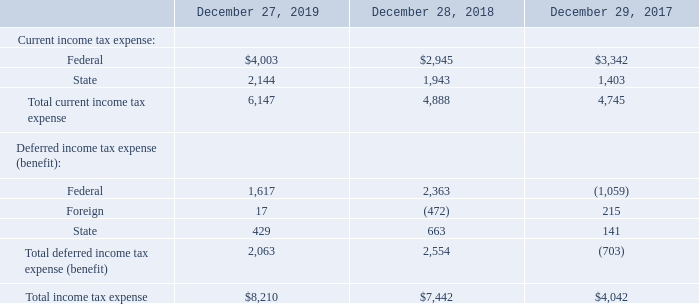Note 12 – Income Taxes
The provision for income taxes consists of the following for the fiscal years ended December 27, 2019, December 28, 2018 and December 29, 2017:
What is the total current income tax expense for 2019, 2018 and 2017 respectively? 6,147, 4,888, 4,745. What is the total income tax expense for 2019, 2018 and 2017 respectively? $8,210, $7,442, $4,042. What is the Total deferred income tax expense (benefit) for 2019, 2018 and 2017 respectively? 2,063, 2,554, (703). What is the change in total income tax expense between 2019 and 2018? 8,210-7,442
Answer: 768. What is the average Total income tax expense for 2019, 2018 and 2017? (8,210+ 7,442+ 4,042)/3
Answer: 6564.67. Which year has the highest Total income tax expense? 8,210> 7,442> 4,042
Answer: 2019. 